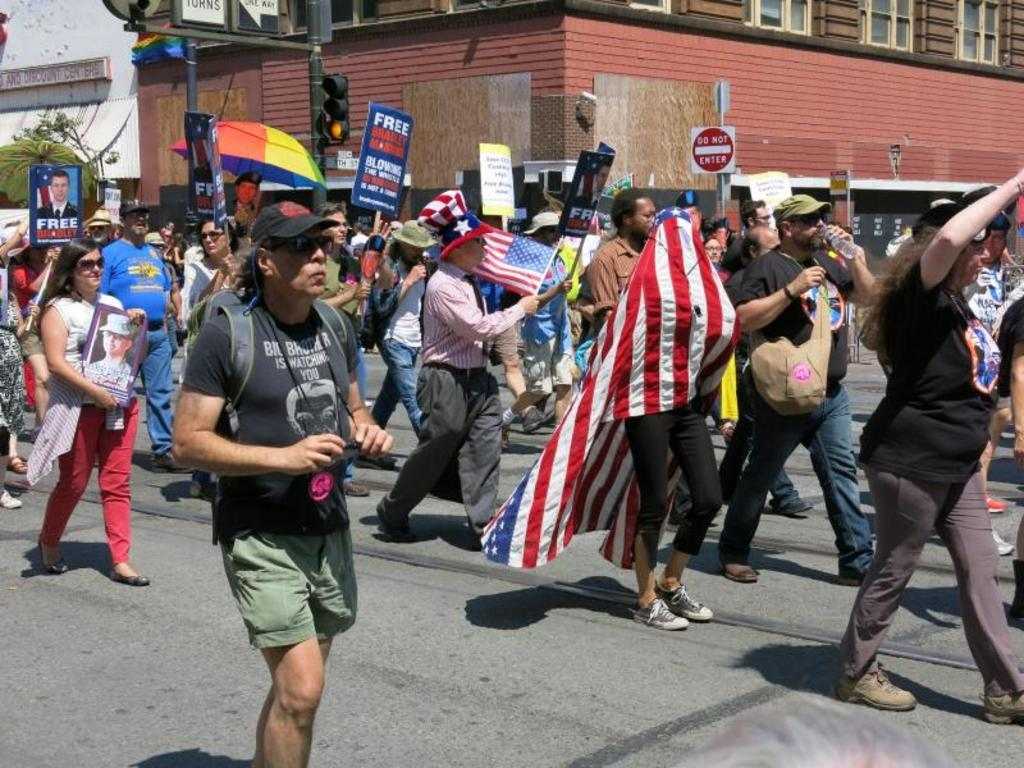What is the main feature of the image? There is a road in the image. What are the people in the image doing? There are people walking on the road. What can be seen in the image besides the road and people? There are flags, signal poles, trees on the left side, boards, and a building in the image. What type of stone is being used to pave the road in the image? There is no mention of stone being used to pave the road in the image; it appears to be a regular asphalt or concrete road. What channel can be seen broadcasting a show on the boards in the image? There is no channel or show visible on the boards in the image; they are likely advertisements or announcements. 